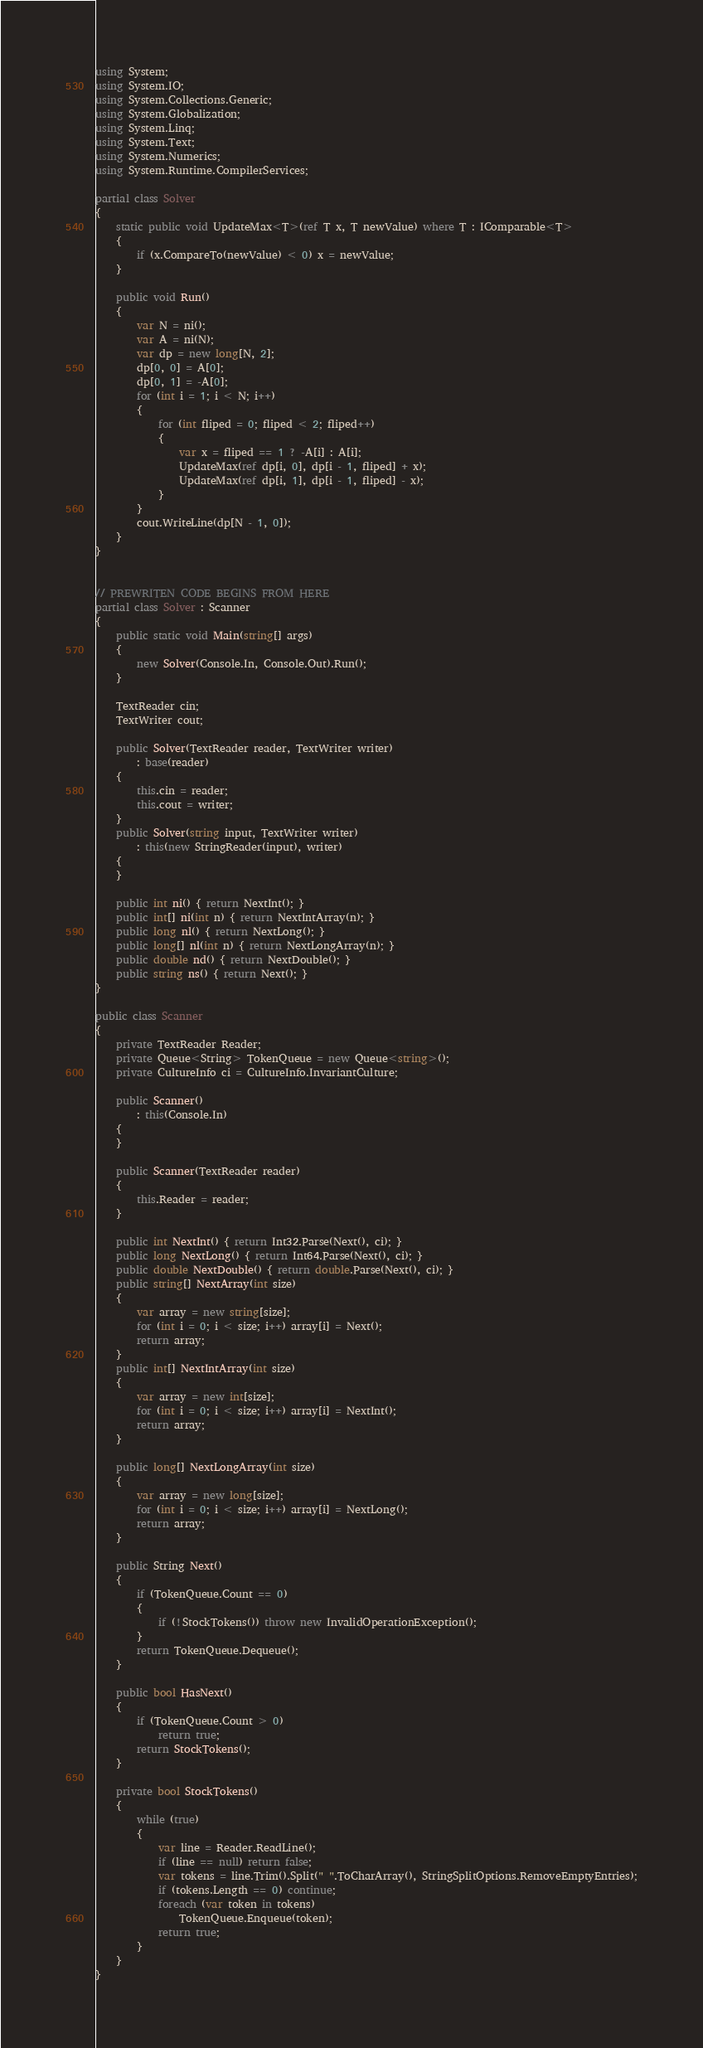<code> <loc_0><loc_0><loc_500><loc_500><_C#_>using System;
using System.IO;
using System.Collections.Generic;
using System.Globalization;
using System.Linq;
using System.Text;
using System.Numerics;
using System.Runtime.CompilerServices;

partial class Solver
{
    static public void UpdateMax<T>(ref T x, T newValue) where T : IComparable<T>
    {
        if (x.CompareTo(newValue) < 0) x = newValue;
    }

    public void Run()
    {
        var N = ni();
        var A = ni(N);
        var dp = new long[N, 2];
        dp[0, 0] = A[0];
        dp[0, 1] = -A[0];
        for (int i = 1; i < N; i++)
        {
            for (int fliped = 0; fliped < 2; fliped++)
            {
                var x = fliped == 1 ? -A[i] : A[i];
                UpdateMax(ref dp[i, 0], dp[i - 1, fliped] + x);
                UpdateMax(ref dp[i, 1], dp[i - 1, fliped] - x);
            }
        }
        cout.WriteLine(dp[N - 1, 0]);
    }
}


// PREWRITEN CODE BEGINS FROM HERE
partial class Solver : Scanner
{
    public static void Main(string[] args)
    {
        new Solver(Console.In, Console.Out).Run();
    }

    TextReader cin;
    TextWriter cout;

    public Solver(TextReader reader, TextWriter writer)
        : base(reader)
    {
        this.cin = reader;
        this.cout = writer;
    }
    public Solver(string input, TextWriter writer)
        : this(new StringReader(input), writer)
    {
    }

    public int ni() { return NextInt(); }
    public int[] ni(int n) { return NextIntArray(n); }
    public long nl() { return NextLong(); }
    public long[] nl(int n) { return NextLongArray(n); }
    public double nd() { return NextDouble(); }
    public string ns() { return Next(); }
}

public class Scanner
{
    private TextReader Reader;
    private Queue<String> TokenQueue = new Queue<string>();
    private CultureInfo ci = CultureInfo.InvariantCulture;

    public Scanner()
        : this(Console.In)
    {
    }

    public Scanner(TextReader reader)
    {
        this.Reader = reader;
    }

    public int NextInt() { return Int32.Parse(Next(), ci); }
    public long NextLong() { return Int64.Parse(Next(), ci); }
    public double NextDouble() { return double.Parse(Next(), ci); }
    public string[] NextArray(int size)
    {
        var array = new string[size];
        for (int i = 0; i < size; i++) array[i] = Next();
        return array;
    }
    public int[] NextIntArray(int size)
    {
        var array = new int[size];
        for (int i = 0; i < size; i++) array[i] = NextInt();
        return array;
    }

    public long[] NextLongArray(int size)
    {
        var array = new long[size];
        for (int i = 0; i < size; i++) array[i] = NextLong();
        return array;
    }

    public String Next()
    {
        if (TokenQueue.Count == 0)
        {
            if (!StockTokens()) throw new InvalidOperationException();
        }
        return TokenQueue.Dequeue();
    }

    public bool HasNext()
    {
        if (TokenQueue.Count > 0)
            return true;
        return StockTokens();
    }

    private bool StockTokens()
    {
        while (true)
        {
            var line = Reader.ReadLine();
            if (line == null) return false;
            var tokens = line.Trim().Split(" ".ToCharArray(), StringSplitOptions.RemoveEmptyEntries);
            if (tokens.Length == 0) continue;
            foreach (var token in tokens)
                TokenQueue.Enqueue(token);
            return true;
        }
    }
}
</code> 